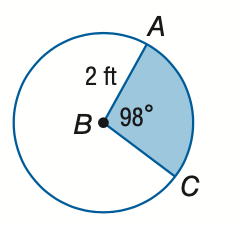Answer the mathemtical geometry problem and directly provide the correct option letter.
Question: Find the area of the shaded sector. Round to the nearest tenth.
Choices: A: 3.4 B: 4.6 C: 9.1 D: 12.6 A 